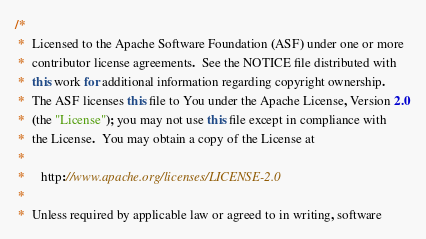<code> <loc_0><loc_0><loc_500><loc_500><_Java_>/*
 *  Licensed to the Apache Software Foundation (ASF) under one or more
 *  contributor license agreements.  See the NOTICE file distributed with
 *  this work for additional information regarding copyright ownership.
 *  The ASF licenses this file to You under the Apache License, Version 2.0
 *  (the "License"); you may not use this file except in compliance with
 *  the License.  You may obtain a copy of the License at
 *
 *     http://www.apache.org/licenses/LICENSE-2.0
 *
 *  Unless required by applicable law or agreed to in writing, software</code> 